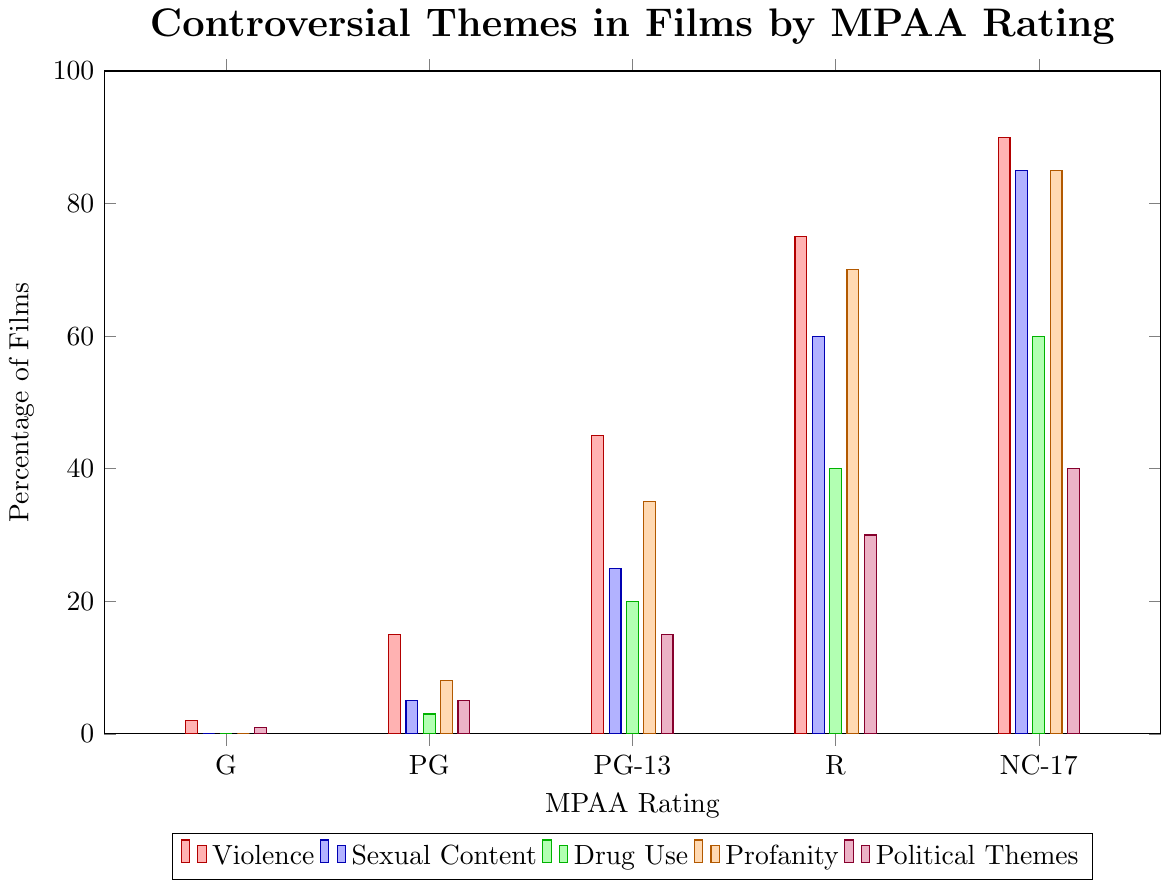What's the percentage of films featuring violence for PG-13 and R ratings? From the chart, observe the height of the red bars representing violence for PG-13 and R ratings. PG-13 has 45% and R has 75%.
Answer: PG-13: 45%, R: 75% Which MPAA rating has the highest percentage of films featuring political themes? Look for the highest purple bar among all the MPAA ratings. NC-17 rating has the highest bar for political themes at 40%.
Answer: NC-17 What is the total percentage of films featuring drug use across all MPAA ratings? Add the green bar values for each MPAA rating: 0 (G) + 3 (PG) + 20 (PG-13) + 40 (R) + 60 (NC-17) = 123
Answer: 123% How does the percentage of films featuring profanity compare between PG and PG-13 ratings? Compare the height of the orange bars for PG and PG-13 ratings. PG has 8% and PG-13 has 35%. So PG-13 has 27% more profanity than PG.
Answer: PG-13 has 27% more Which controversial theme increases the most from PG to PG-13 ratings? Calculate the differences for each theme: Violence (45 - 15 = 30), Sexual Content (25 - 5 = 20), Drug Use (20 - 3 = 17), Profanity (35 - 8 = 27), Political Themes (15 - 5 = 10). Violence has the highest increase of 30%.
Answer: Violence What is the average percentage of films featuring sexual content in PG-13, R, and NC-17 ratings? Add the values for sexual content in PG-13 (25), R (60), and NC-17 (85), then divide by 3: (25 + 60 + 85) / 3 = 170 / 3 ≈ 56.67
Answer: 56.67% In which rating category is drug use least prevalent? Look for the shortest green bar among all the MPAA ratings. Both G and PG categories have 0%, but since both are options, we choose one. We'll go with 'G'.
Answer: G How does the representation of violence in R-rated films compare to NC-17 rated films? Look at the red bars for R and NC-17 ratings. R has 75% and NC-17 has 90%. NC-17 has 15% more violence than R.
Answer: NC-17 has 15% more If you sum up the percentages of all controversial themes for the PG rating, what do you get? Add the percentages for each theme in PG: 15 (Violence) + 5 (Sexual Content) + 3 (Drug Use) + 8 (Profanity) + 5 (Political Themes) = 36
Answer: 36% 